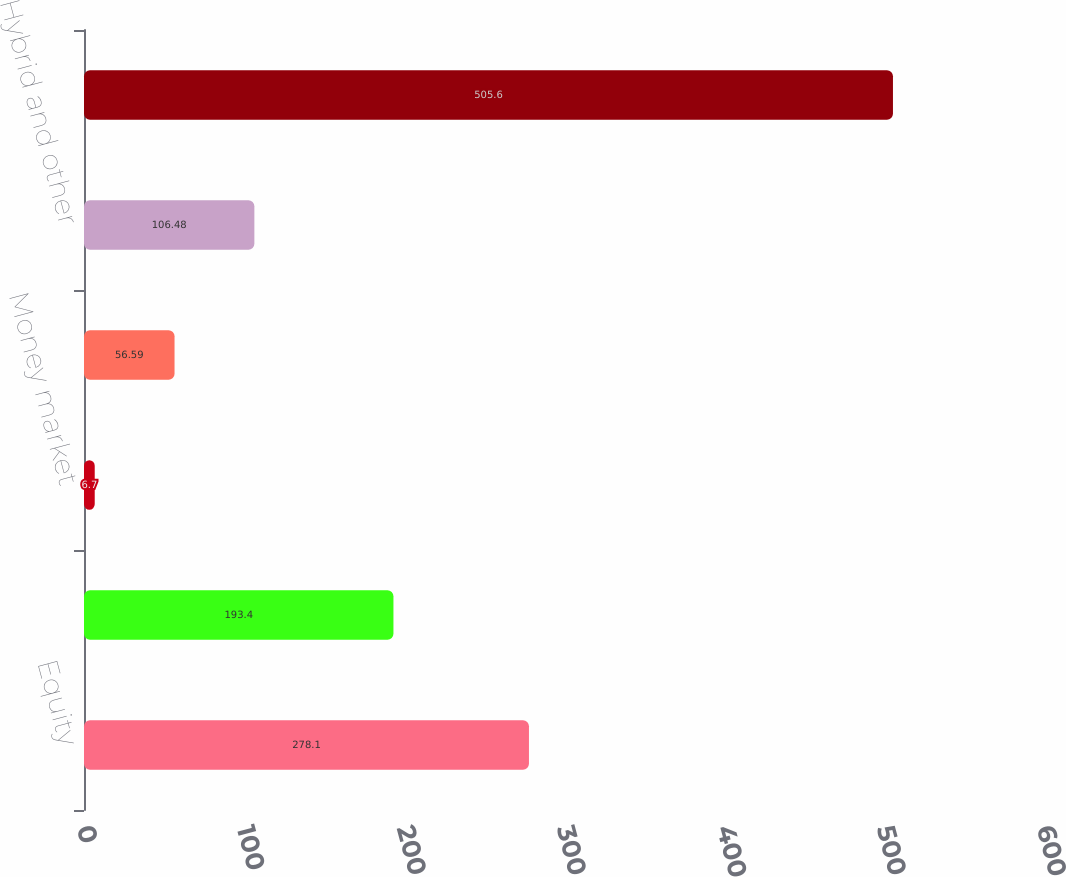Convert chart. <chart><loc_0><loc_0><loc_500><loc_500><bar_chart><fcel>Equity<fcel>Fixed income<fcel>Money market<fcel>Alternative<fcel>Hybrid and other<fcel>Total managed assets<nl><fcel>278.1<fcel>193.4<fcel>6.7<fcel>56.59<fcel>106.48<fcel>505.6<nl></chart> 